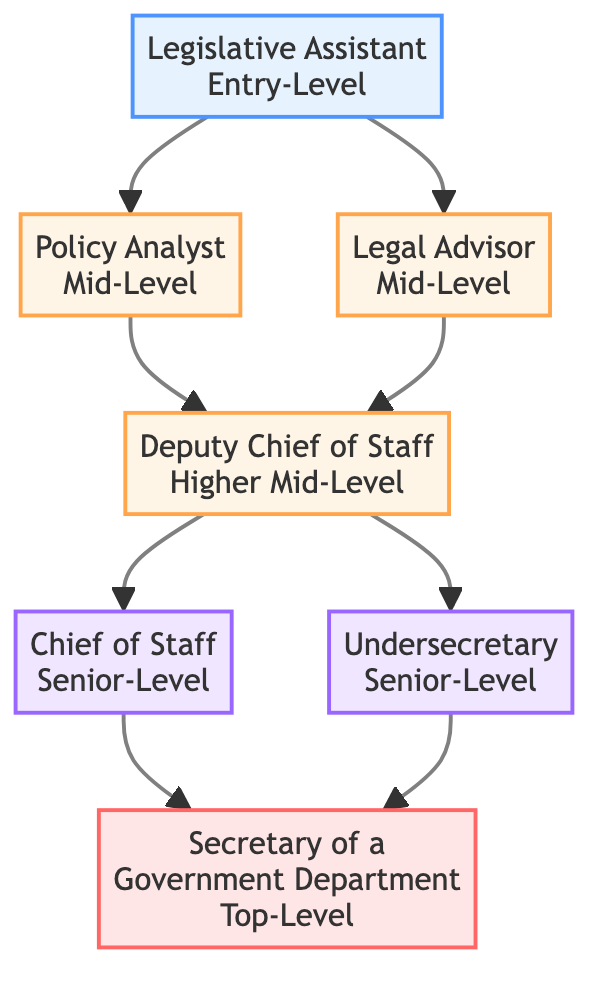What is the entry-level position in this career pathway? The entry-level position is identified directly in the diagram as the first node at the bottom, which is "Legislative Assistant."
Answer: Legislative Assistant How many mid-level positions are in the diagram? By counting the nodes that are labeled as mid-level, there are two mid-level positions listed: "Policy Analyst" and "Legal Advisor."
Answer: 2 What is the highest position in the career pathway? The highest position can be determined by looking at the top node in the diagram, which is labeled "Secretary of a Government Department."
Answer: Secretary of a Government Department Which position requires experience as a legislative assistant? This position can be found by tracing the flow from the Legislative Assistant node upward; the "Policy Analyst" position is the one that requires such experience.
Answer: Policy Analyst What are the requirements for the position of Chief of Staff? To find the requirements, refer to the description provided in the node labeled "Chief of Staff," which states the need for extensive experience in government, leadership acumen, and strong decision-making abilities.
Answer: Extensive experience in government, leadership acumen, strong decision-making abilities Which positions lead to the Secretary of a Government Department? By examining the connections in the diagram, both "Chief of Staff" and "Undersecretary" lead directly to the "Secretary of a Government Department."
Answer: Chief of Staff, Undersecretary What is the level of the position "Deputy Chief of Staff"? This can be answered by identifying the node for "Deputy Chief of Staff," which is labeled as a higher mid-level position in the diagram.
Answer: Higher Mid-Level What is common between the positions of Chief of Staff and Undersecretary in terms of level? The commonality is that both positions are categorized as senior-level in the diagram, indicating a similar hierarchy.
Answer: Senior-Level 